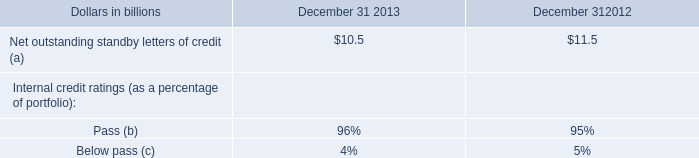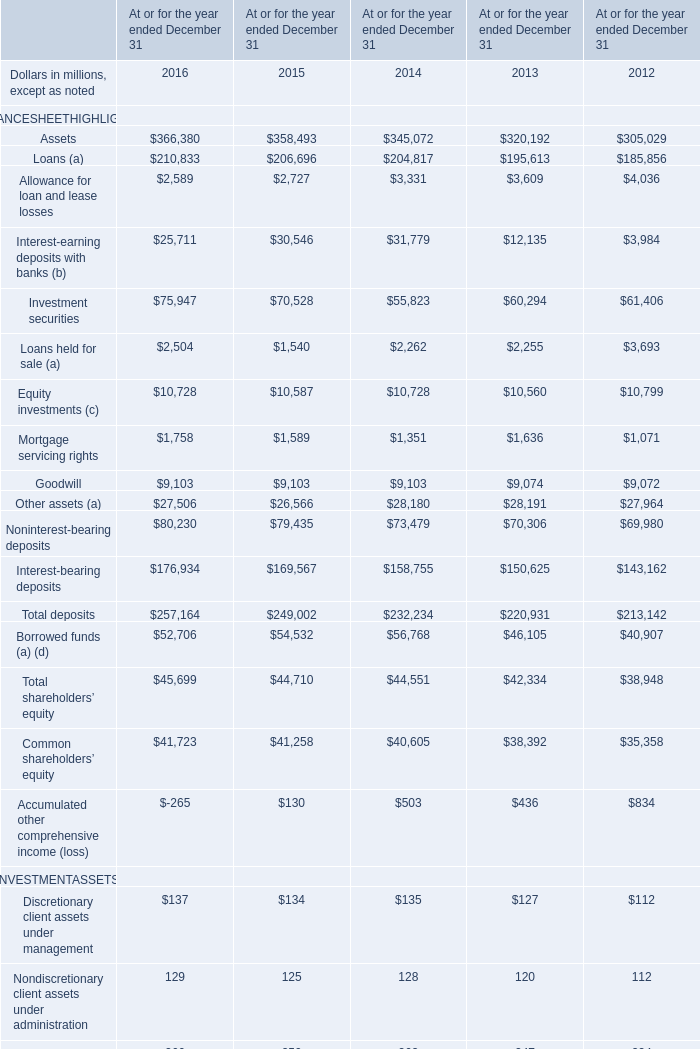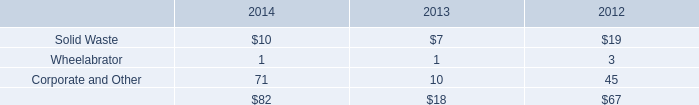what was the change in billions in remarketing programs between december 31 , 2013 and december 31 , 2012? 
Computations: (7.5 - 6.6)
Answer: 0.9. 